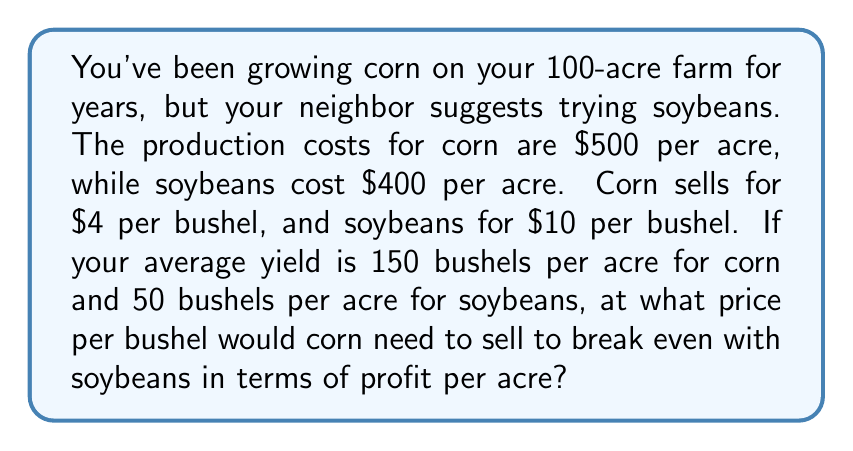Show me your answer to this math problem. Let's approach this step-by-step:

1) First, calculate the revenue per acre for soybeans:
   $$ \text{Soybean Revenue} = 50 \text{ bushels} \times \$10 = \$500 \text{ per acre} $$

2) Calculate the profit per acre for soybeans:
   $$ \text{Soybean Profit} = \$500 - \$400 = \$100 \text{ per acre} $$

3) Now, let's set up an equation for corn to break even with soybeans:
   $$ 150x - \$500 = \$100 $$
   Where $x$ is the price per bushel of corn we're solving for.

4) Solve the equation:
   $$ 150x = \$600 $$
   $$ x = \frac{\$600}{150} = \$4 \text{ per bushel} $$

Therefore, corn needs to sell at $4 per bushel to break even with soybeans in terms of profit per acre.

5) Double-check:
   Corn revenue at $4/bushel: $$ 150 \times \$4 = \$600 $$
   Corn profit: $$ \$600 - \$500 = \$100 \text{ per acre} $$

This matches the soybean profit, confirming our calculation.
Answer: $4 per bushel 